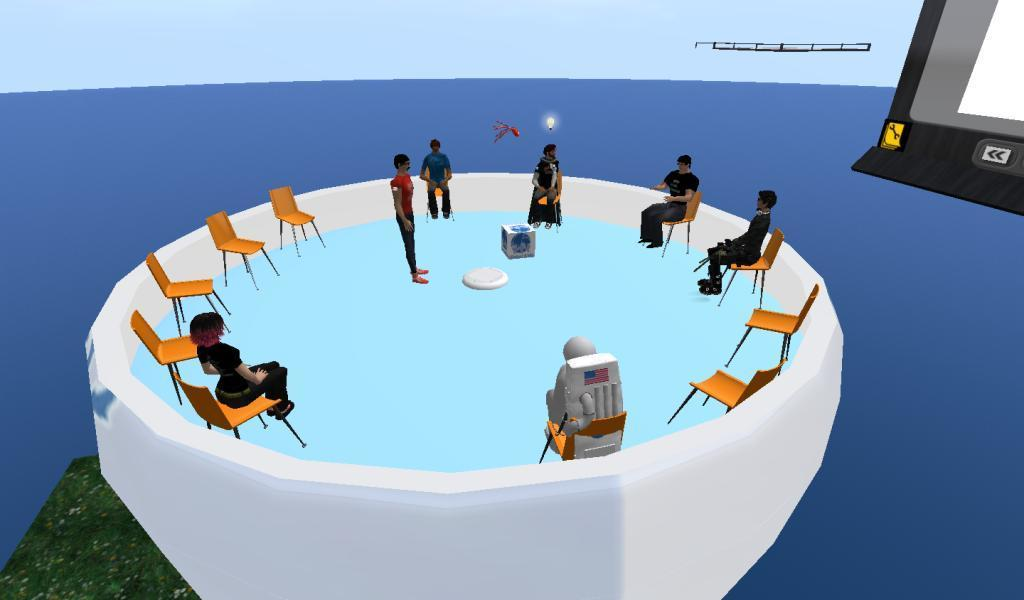What type of furniture is visible in the image? There are chairs in the image. What are the chairs being used for? There are people sitting on the chairs. What can be observed around the people in the image? There is a blue color thing around the people, possibly a background or a frame. How was the image created? The image is a depiction, meaning it is not a photograph but likely a drawing or painting. Is there a boat visible in the image? No, there is no boat present in the image. Can you fold the people sitting on the chairs? No, the people in the image are not physical objects that can be folded. 